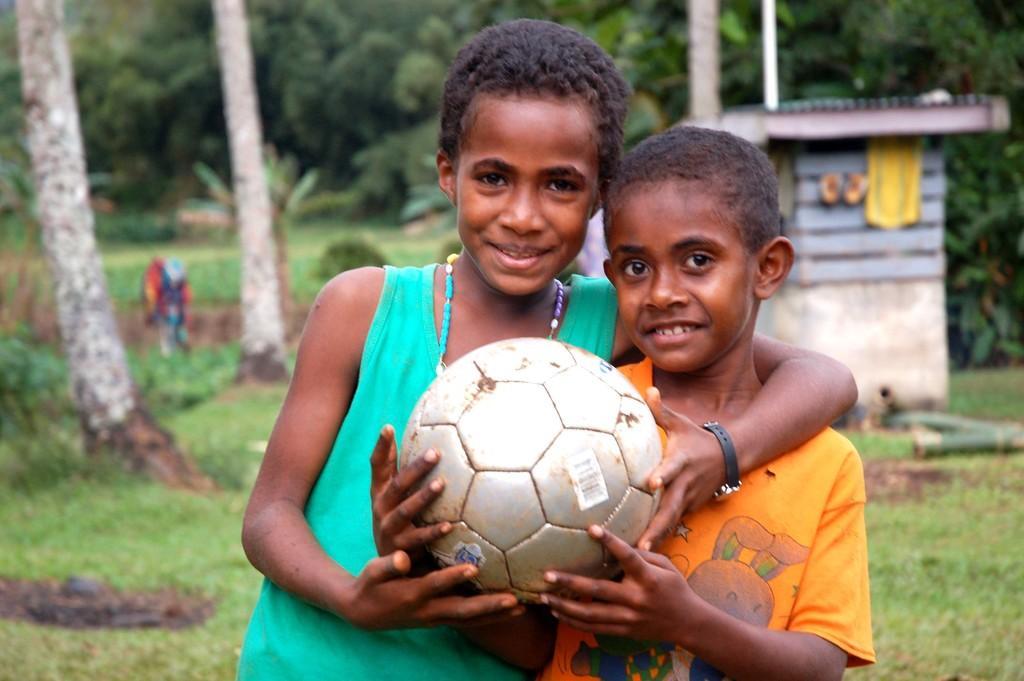Can you describe this image briefly? In this image there are two kids who are holding a ball in there hands and at the background of the image there are trees. 